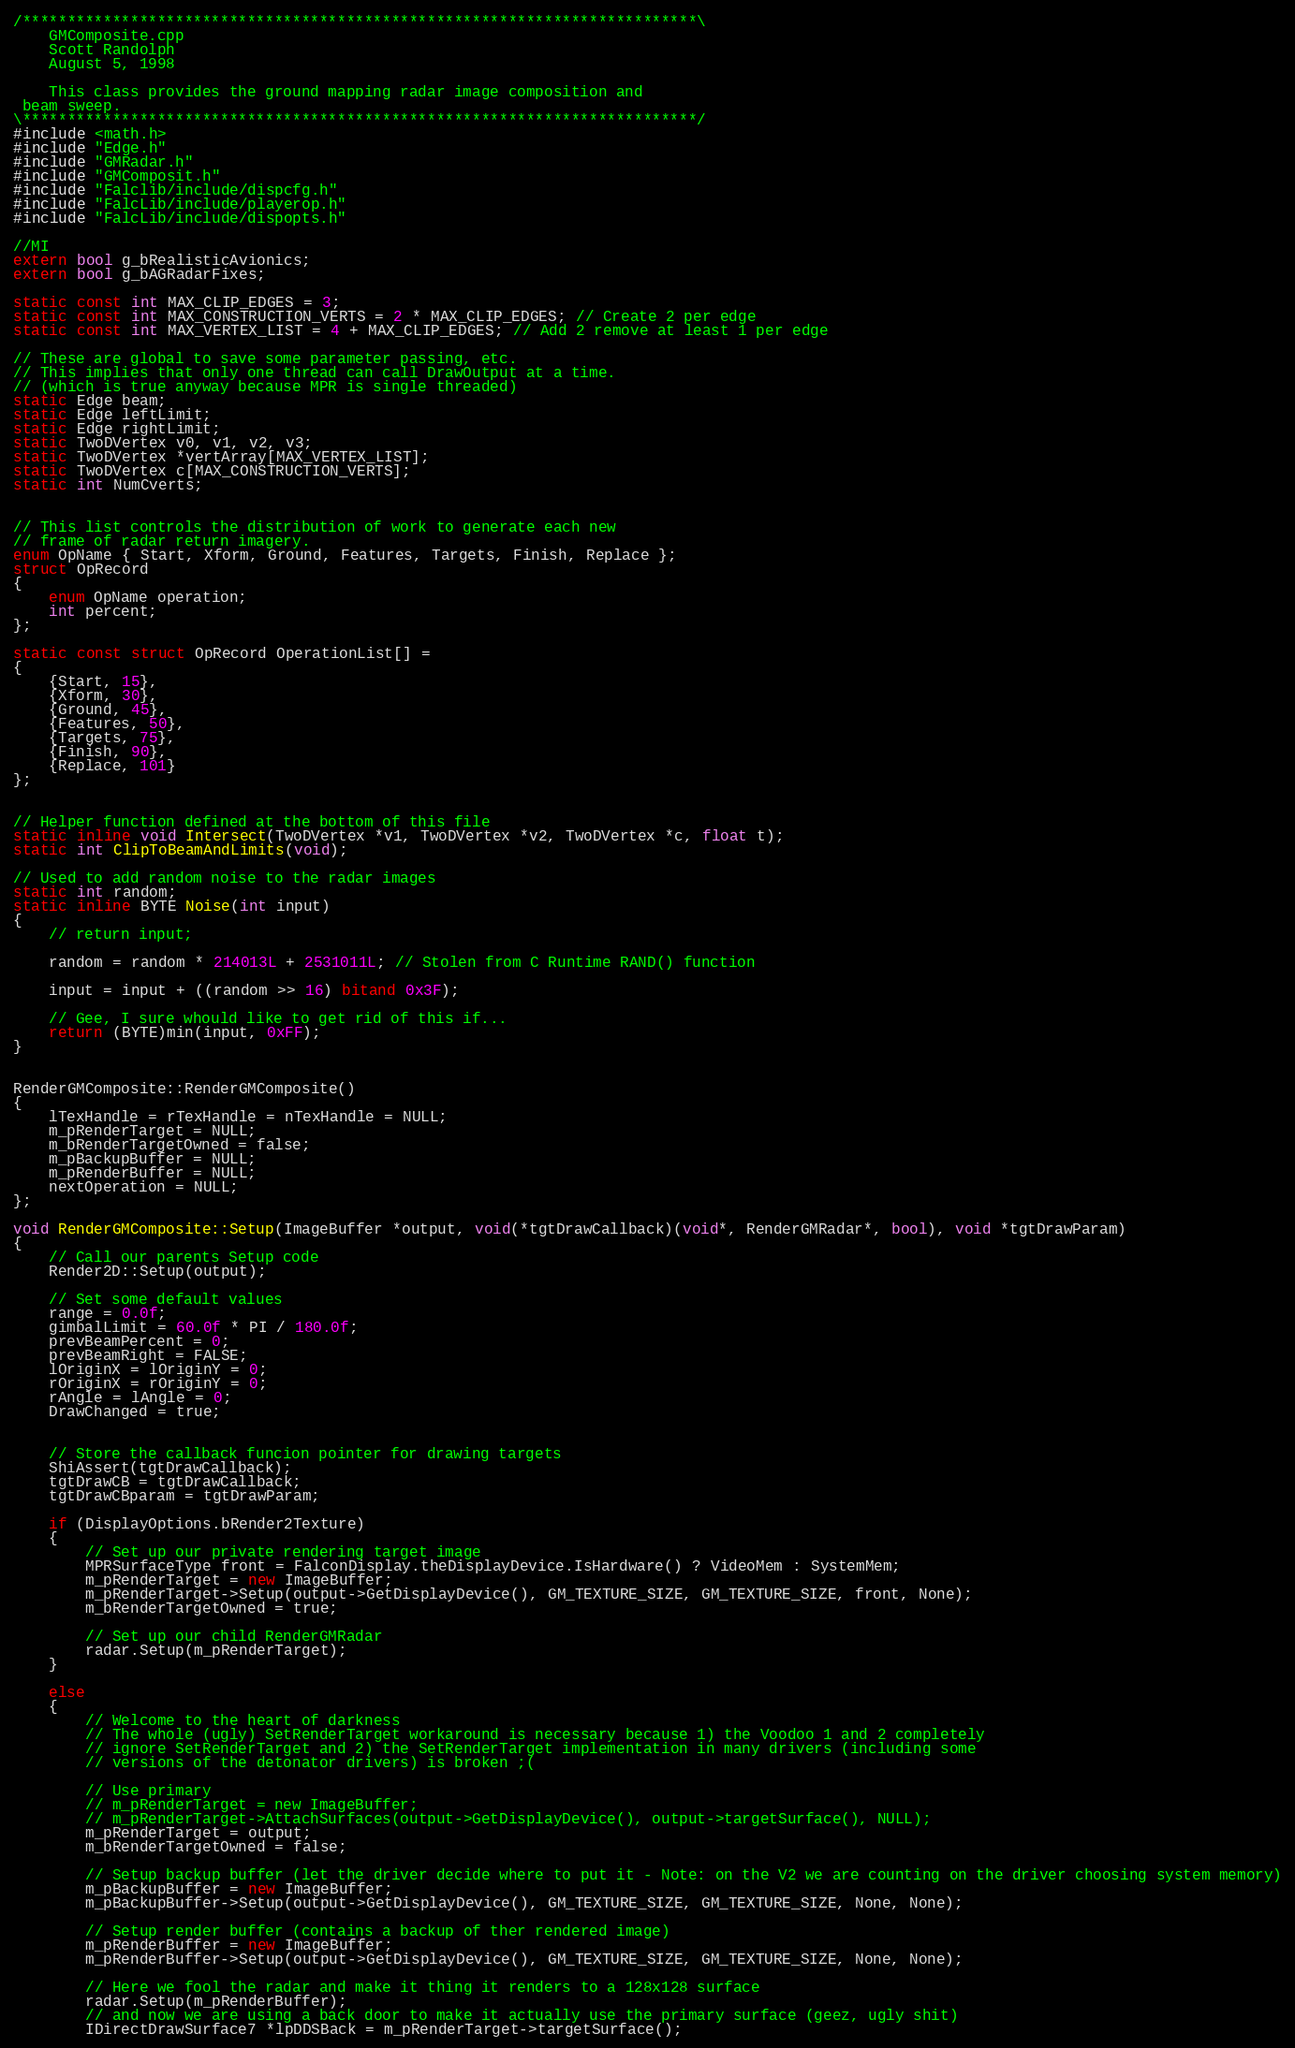Convert code to text. <code><loc_0><loc_0><loc_500><loc_500><_C++_>/***************************************************************************\
    GMComposite.cpp
    Scott Randolph
    August 5, 1998

    This class provides the ground mapping radar image composition and
 beam sweep.
\***************************************************************************/
#include <math.h>
#include "Edge.h"
#include "GMRadar.h"
#include "GMComposit.h"
#include "Falclib/include/dispcfg.h"
#include "FalcLib/include/playerop.h"
#include "FalcLib/include/dispopts.h"

//MI
extern bool g_bRealisticAvionics;
extern bool g_bAGRadarFixes;

static const int MAX_CLIP_EDGES = 3;
static const int MAX_CONSTRUCTION_VERTS = 2 * MAX_CLIP_EDGES; // Create 2 per edge
static const int MAX_VERTEX_LIST = 4 + MAX_CLIP_EDGES; // Add 2 remove at least 1 per edge

// These are global to save some parameter passing, etc.
// This implies that only one thread can call DrawOutput at a time.
// (which is true anyway because MPR is single threaded)
static Edge beam;
static Edge leftLimit;
static Edge rightLimit;
static TwoDVertex v0, v1, v2, v3;
static TwoDVertex *vertArray[MAX_VERTEX_LIST];
static TwoDVertex c[MAX_CONSTRUCTION_VERTS];
static int NumCverts;


// This list controls the distribution of work to generate each new
// frame of radar return imagery.
enum OpName { Start, Xform, Ground, Features, Targets, Finish, Replace };
struct OpRecord
{
    enum OpName operation;
    int percent;
};

static const struct OpRecord OperationList[] =
{
    {Start, 15},
    {Xform, 30},
    {Ground, 45},
    {Features, 50},
    {Targets, 75},
    {Finish, 90},
    {Replace, 101}
};


// Helper function defined at the bottom of this file
static inline void Intersect(TwoDVertex *v1, TwoDVertex *v2, TwoDVertex *c, float t);
static int ClipToBeamAndLimits(void);

// Used to add random noise to the radar images
static int random;
static inline BYTE Noise(int input)
{
    // return input;

    random = random * 214013L + 2531011L; // Stolen from C Runtime RAND() function

    input = input + ((random >> 16) bitand 0x3F);

    // Gee, I sure whould like to get rid of this if...
    return (BYTE)min(input, 0xFF);
}


RenderGMComposite::RenderGMComposite()
{
    lTexHandle = rTexHandle = nTexHandle = NULL;
    m_pRenderTarget = NULL;
    m_bRenderTargetOwned = false;
    m_pBackupBuffer = NULL;
    m_pRenderBuffer = NULL;
    nextOperation = NULL;
};

void RenderGMComposite::Setup(ImageBuffer *output, void(*tgtDrawCallback)(void*, RenderGMRadar*, bool), void *tgtDrawParam)
{
    // Call our parents Setup code
    Render2D::Setup(output);

    // Set some default values
    range = 0.0f;
    gimbalLimit = 60.0f * PI / 180.0f;
    prevBeamPercent = 0;
    prevBeamRight = FALSE;
    lOriginX = lOriginY = 0;
    rOriginX = rOriginY = 0;
    rAngle = lAngle = 0;
    DrawChanged = true;


    // Store the callback funcion pointer for drawing targets
    ShiAssert(tgtDrawCallback);
    tgtDrawCB = tgtDrawCallback;
    tgtDrawCBparam = tgtDrawParam;

    if (DisplayOptions.bRender2Texture)
    {
        // Set up our private rendering target image
        MPRSurfaceType front = FalconDisplay.theDisplayDevice.IsHardware() ? VideoMem : SystemMem;
        m_pRenderTarget = new ImageBuffer;
        m_pRenderTarget->Setup(output->GetDisplayDevice(), GM_TEXTURE_SIZE, GM_TEXTURE_SIZE, front, None);
        m_bRenderTargetOwned = true;

        // Set up our child RenderGMRadar
        radar.Setup(m_pRenderTarget);
    }

    else
    {
        // Welcome to the heart of darkness
        // The whole (ugly) SetRenderTarget workaround is necessary because 1) the Voodoo 1 and 2 completely
        // ignore SetRenderTarget and 2) the SetRenderTarget implementation in many drivers (including some
        // versions of the detonator drivers) is broken ;(

        // Use primary
        // m_pRenderTarget = new ImageBuffer;
        // m_pRenderTarget->AttachSurfaces(output->GetDisplayDevice(), output->targetSurface(), NULL);
        m_pRenderTarget = output;
        m_bRenderTargetOwned = false;

        // Setup backup buffer (let the driver decide where to put it - Note: on the V2 we are counting on the driver choosing system memory)
        m_pBackupBuffer = new ImageBuffer;
        m_pBackupBuffer->Setup(output->GetDisplayDevice(), GM_TEXTURE_SIZE, GM_TEXTURE_SIZE, None, None);

        // Setup render buffer (contains a backup of ther rendered image)
        m_pRenderBuffer = new ImageBuffer;
        m_pRenderBuffer->Setup(output->GetDisplayDevice(), GM_TEXTURE_SIZE, GM_TEXTURE_SIZE, None, None);

        // Here we fool the radar and make it thing it renders to a 128x128 surface
        radar.Setup(m_pRenderBuffer);
        // and now we are using a back door to make it actually use the primary surface (geez, ugly shit)
        IDirectDrawSurface7 *lpDDSBack = m_pRenderTarget->targetSurface();</code> 